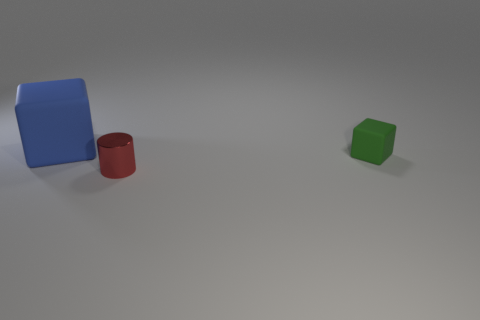Add 2 brown shiny blocks. How many objects exist? 5 Subtract all cylinders. How many objects are left? 2 Subtract all large matte balls. Subtract all red objects. How many objects are left? 2 Add 3 cylinders. How many cylinders are left? 4 Add 3 large blue balls. How many large blue balls exist? 3 Subtract 0 purple cylinders. How many objects are left? 3 Subtract all gray blocks. Subtract all brown cylinders. How many blocks are left? 2 Subtract all red cubes. How many cyan cylinders are left? 0 